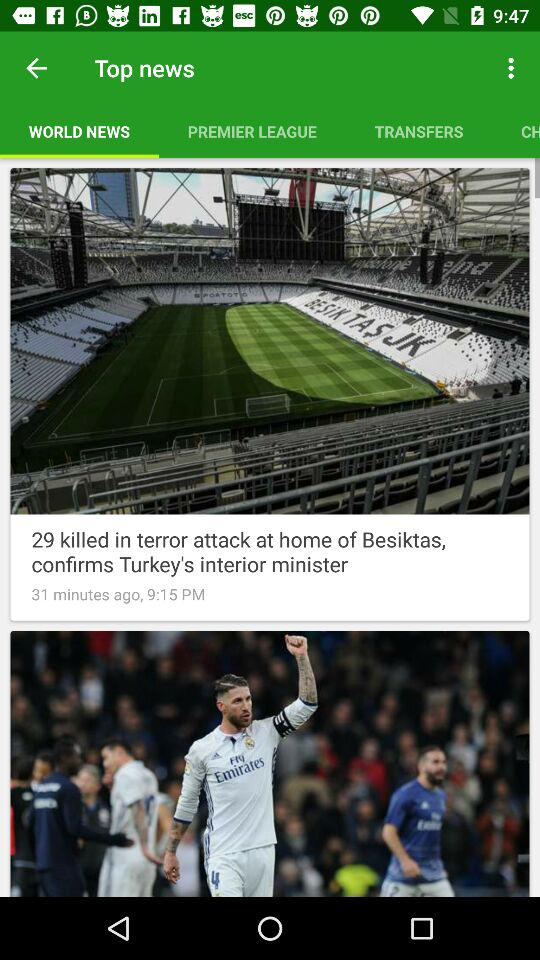At what time was the news "terror attack at home of Besiktas" published? The news was published at 9:15 p.m. 